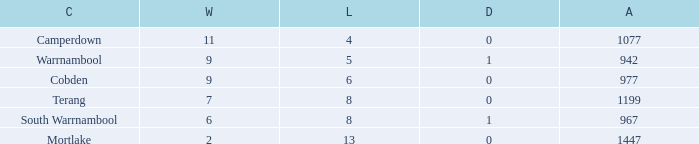What's the number of losses when the wins were more than 11 and had 0 draws? 0.0. 